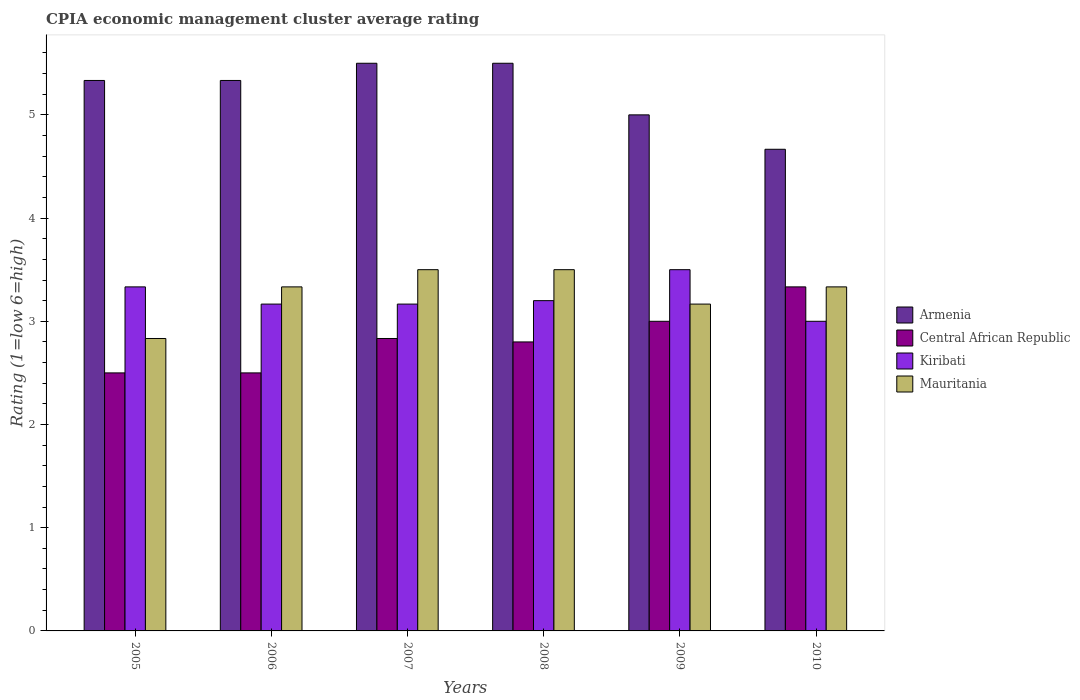How many different coloured bars are there?
Your answer should be compact. 4. How many groups of bars are there?
Your answer should be compact. 6. How many bars are there on the 3rd tick from the left?
Give a very brief answer. 4. How many bars are there on the 1st tick from the right?
Offer a very short reply. 4. What is the label of the 4th group of bars from the left?
Your response must be concise. 2008. In how many cases, is the number of bars for a given year not equal to the number of legend labels?
Your answer should be compact. 0. Across all years, what is the maximum CPIA rating in Mauritania?
Ensure brevity in your answer.  3.5. Across all years, what is the minimum CPIA rating in Armenia?
Provide a short and direct response. 4.67. In which year was the CPIA rating in Armenia maximum?
Your response must be concise. 2007. What is the total CPIA rating in Armenia in the graph?
Your answer should be compact. 31.33. What is the difference between the CPIA rating in Central African Republic in 2007 and that in 2008?
Provide a short and direct response. 0.03. What is the difference between the CPIA rating in Central African Republic in 2010 and the CPIA rating in Mauritania in 2009?
Give a very brief answer. 0.17. What is the average CPIA rating in Central African Republic per year?
Give a very brief answer. 2.83. In the year 2010, what is the difference between the CPIA rating in Armenia and CPIA rating in Mauritania?
Give a very brief answer. 1.33. In how many years, is the CPIA rating in Mauritania greater than 2.2?
Your response must be concise. 6. What is the ratio of the CPIA rating in Mauritania in 2005 to that in 2006?
Your response must be concise. 0.85. Is the difference between the CPIA rating in Armenia in 2008 and 2009 greater than the difference between the CPIA rating in Mauritania in 2008 and 2009?
Your answer should be compact. Yes. What is the difference between the highest and the lowest CPIA rating in Central African Republic?
Provide a succinct answer. 0.83. In how many years, is the CPIA rating in Central African Republic greater than the average CPIA rating in Central African Republic taken over all years?
Ensure brevity in your answer.  3. Is the sum of the CPIA rating in Kiribati in 2005 and 2006 greater than the maximum CPIA rating in Mauritania across all years?
Ensure brevity in your answer.  Yes. What does the 2nd bar from the left in 2010 represents?
Offer a terse response. Central African Republic. What does the 3rd bar from the right in 2009 represents?
Make the answer very short. Central African Republic. Is it the case that in every year, the sum of the CPIA rating in Kiribati and CPIA rating in Armenia is greater than the CPIA rating in Mauritania?
Give a very brief answer. Yes. Are all the bars in the graph horizontal?
Ensure brevity in your answer.  No. How many years are there in the graph?
Make the answer very short. 6. Are the values on the major ticks of Y-axis written in scientific E-notation?
Provide a succinct answer. No. Does the graph contain grids?
Give a very brief answer. No. What is the title of the graph?
Your answer should be compact. CPIA economic management cluster average rating. What is the label or title of the Y-axis?
Give a very brief answer. Rating (1=low 6=high). What is the Rating (1=low 6=high) of Armenia in 2005?
Offer a terse response. 5.33. What is the Rating (1=low 6=high) of Kiribati in 2005?
Provide a short and direct response. 3.33. What is the Rating (1=low 6=high) of Mauritania in 2005?
Your answer should be compact. 2.83. What is the Rating (1=low 6=high) of Armenia in 2006?
Provide a short and direct response. 5.33. What is the Rating (1=low 6=high) in Central African Republic in 2006?
Your answer should be very brief. 2.5. What is the Rating (1=low 6=high) of Kiribati in 2006?
Your response must be concise. 3.17. What is the Rating (1=low 6=high) of Mauritania in 2006?
Give a very brief answer. 3.33. What is the Rating (1=low 6=high) in Central African Republic in 2007?
Your answer should be compact. 2.83. What is the Rating (1=low 6=high) of Kiribati in 2007?
Ensure brevity in your answer.  3.17. What is the Rating (1=low 6=high) of Armenia in 2008?
Your answer should be very brief. 5.5. What is the Rating (1=low 6=high) of Armenia in 2009?
Your answer should be very brief. 5. What is the Rating (1=low 6=high) of Mauritania in 2009?
Offer a very short reply. 3.17. What is the Rating (1=low 6=high) in Armenia in 2010?
Your answer should be very brief. 4.67. What is the Rating (1=low 6=high) of Central African Republic in 2010?
Give a very brief answer. 3.33. What is the Rating (1=low 6=high) in Kiribati in 2010?
Offer a terse response. 3. What is the Rating (1=low 6=high) of Mauritania in 2010?
Offer a very short reply. 3.33. Across all years, what is the maximum Rating (1=low 6=high) in Armenia?
Offer a terse response. 5.5. Across all years, what is the maximum Rating (1=low 6=high) in Central African Republic?
Your answer should be very brief. 3.33. Across all years, what is the minimum Rating (1=low 6=high) in Armenia?
Make the answer very short. 4.67. Across all years, what is the minimum Rating (1=low 6=high) in Central African Republic?
Your answer should be compact. 2.5. Across all years, what is the minimum Rating (1=low 6=high) of Kiribati?
Your answer should be very brief. 3. Across all years, what is the minimum Rating (1=low 6=high) of Mauritania?
Your response must be concise. 2.83. What is the total Rating (1=low 6=high) in Armenia in the graph?
Make the answer very short. 31.33. What is the total Rating (1=low 6=high) in Central African Republic in the graph?
Your answer should be very brief. 16.97. What is the total Rating (1=low 6=high) in Kiribati in the graph?
Your answer should be compact. 19.37. What is the total Rating (1=low 6=high) in Mauritania in the graph?
Ensure brevity in your answer.  19.67. What is the difference between the Rating (1=low 6=high) in Armenia in 2005 and that in 2006?
Ensure brevity in your answer.  0. What is the difference between the Rating (1=low 6=high) of Central African Republic in 2005 and that in 2006?
Make the answer very short. 0. What is the difference between the Rating (1=low 6=high) of Kiribati in 2005 and that in 2006?
Keep it short and to the point. 0.17. What is the difference between the Rating (1=low 6=high) of Kiribati in 2005 and that in 2007?
Keep it short and to the point. 0.17. What is the difference between the Rating (1=low 6=high) in Central African Republic in 2005 and that in 2008?
Make the answer very short. -0.3. What is the difference between the Rating (1=low 6=high) of Kiribati in 2005 and that in 2008?
Make the answer very short. 0.13. What is the difference between the Rating (1=low 6=high) of Armenia in 2005 and that in 2010?
Provide a succinct answer. 0.67. What is the difference between the Rating (1=low 6=high) of Central African Republic in 2005 and that in 2010?
Your answer should be compact. -0.83. What is the difference between the Rating (1=low 6=high) of Central African Republic in 2006 and that in 2007?
Make the answer very short. -0.33. What is the difference between the Rating (1=low 6=high) of Kiribati in 2006 and that in 2007?
Ensure brevity in your answer.  0. What is the difference between the Rating (1=low 6=high) in Mauritania in 2006 and that in 2007?
Provide a succinct answer. -0.17. What is the difference between the Rating (1=low 6=high) in Armenia in 2006 and that in 2008?
Provide a succinct answer. -0.17. What is the difference between the Rating (1=low 6=high) in Kiribati in 2006 and that in 2008?
Offer a terse response. -0.03. What is the difference between the Rating (1=low 6=high) in Armenia in 2006 and that in 2009?
Make the answer very short. 0.33. What is the difference between the Rating (1=low 6=high) in Central African Republic in 2006 and that in 2009?
Offer a terse response. -0.5. What is the difference between the Rating (1=low 6=high) in Mauritania in 2006 and that in 2009?
Offer a very short reply. 0.17. What is the difference between the Rating (1=low 6=high) of Central African Republic in 2006 and that in 2010?
Your response must be concise. -0.83. What is the difference between the Rating (1=low 6=high) of Mauritania in 2006 and that in 2010?
Give a very brief answer. 0. What is the difference between the Rating (1=low 6=high) of Armenia in 2007 and that in 2008?
Ensure brevity in your answer.  0. What is the difference between the Rating (1=low 6=high) in Central African Republic in 2007 and that in 2008?
Offer a very short reply. 0.03. What is the difference between the Rating (1=low 6=high) of Kiribati in 2007 and that in 2008?
Your answer should be very brief. -0.03. What is the difference between the Rating (1=low 6=high) of Mauritania in 2007 and that in 2008?
Give a very brief answer. 0. What is the difference between the Rating (1=low 6=high) in Armenia in 2007 and that in 2009?
Ensure brevity in your answer.  0.5. What is the difference between the Rating (1=low 6=high) in Kiribati in 2007 and that in 2009?
Provide a succinct answer. -0.33. What is the difference between the Rating (1=low 6=high) of Armenia in 2008 and that in 2009?
Offer a very short reply. 0.5. What is the difference between the Rating (1=low 6=high) in Mauritania in 2008 and that in 2009?
Offer a very short reply. 0.33. What is the difference between the Rating (1=low 6=high) in Central African Republic in 2008 and that in 2010?
Offer a terse response. -0.53. What is the difference between the Rating (1=low 6=high) in Kiribati in 2008 and that in 2010?
Provide a succinct answer. 0.2. What is the difference between the Rating (1=low 6=high) in Mauritania in 2008 and that in 2010?
Give a very brief answer. 0.17. What is the difference between the Rating (1=low 6=high) in Armenia in 2009 and that in 2010?
Your response must be concise. 0.33. What is the difference between the Rating (1=low 6=high) in Kiribati in 2009 and that in 2010?
Give a very brief answer. 0.5. What is the difference between the Rating (1=low 6=high) in Mauritania in 2009 and that in 2010?
Offer a very short reply. -0.17. What is the difference between the Rating (1=low 6=high) in Armenia in 2005 and the Rating (1=low 6=high) in Central African Republic in 2006?
Your answer should be compact. 2.83. What is the difference between the Rating (1=low 6=high) in Armenia in 2005 and the Rating (1=low 6=high) in Kiribati in 2006?
Your answer should be very brief. 2.17. What is the difference between the Rating (1=low 6=high) in Armenia in 2005 and the Rating (1=low 6=high) in Mauritania in 2006?
Make the answer very short. 2. What is the difference between the Rating (1=low 6=high) of Kiribati in 2005 and the Rating (1=low 6=high) of Mauritania in 2006?
Give a very brief answer. 0. What is the difference between the Rating (1=low 6=high) of Armenia in 2005 and the Rating (1=low 6=high) of Central African Republic in 2007?
Your answer should be very brief. 2.5. What is the difference between the Rating (1=low 6=high) of Armenia in 2005 and the Rating (1=low 6=high) of Kiribati in 2007?
Provide a short and direct response. 2.17. What is the difference between the Rating (1=low 6=high) of Armenia in 2005 and the Rating (1=low 6=high) of Mauritania in 2007?
Make the answer very short. 1.83. What is the difference between the Rating (1=low 6=high) of Central African Republic in 2005 and the Rating (1=low 6=high) of Kiribati in 2007?
Your answer should be very brief. -0.67. What is the difference between the Rating (1=low 6=high) of Central African Republic in 2005 and the Rating (1=low 6=high) of Mauritania in 2007?
Offer a terse response. -1. What is the difference between the Rating (1=low 6=high) of Kiribati in 2005 and the Rating (1=low 6=high) of Mauritania in 2007?
Your answer should be compact. -0.17. What is the difference between the Rating (1=low 6=high) of Armenia in 2005 and the Rating (1=low 6=high) of Central African Republic in 2008?
Provide a succinct answer. 2.53. What is the difference between the Rating (1=low 6=high) in Armenia in 2005 and the Rating (1=low 6=high) in Kiribati in 2008?
Offer a terse response. 2.13. What is the difference between the Rating (1=low 6=high) in Armenia in 2005 and the Rating (1=low 6=high) in Mauritania in 2008?
Give a very brief answer. 1.83. What is the difference between the Rating (1=low 6=high) in Central African Republic in 2005 and the Rating (1=low 6=high) in Kiribati in 2008?
Ensure brevity in your answer.  -0.7. What is the difference between the Rating (1=low 6=high) of Central African Republic in 2005 and the Rating (1=low 6=high) of Mauritania in 2008?
Offer a terse response. -1. What is the difference between the Rating (1=low 6=high) of Armenia in 2005 and the Rating (1=low 6=high) of Central African Republic in 2009?
Offer a terse response. 2.33. What is the difference between the Rating (1=low 6=high) in Armenia in 2005 and the Rating (1=low 6=high) in Kiribati in 2009?
Ensure brevity in your answer.  1.83. What is the difference between the Rating (1=low 6=high) in Armenia in 2005 and the Rating (1=low 6=high) in Mauritania in 2009?
Keep it short and to the point. 2.17. What is the difference between the Rating (1=low 6=high) of Kiribati in 2005 and the Rating (1=low 6=high) of Mauritania in 2009?
Give a very brief answer. 0.17. What is the difference between the Rating (1=low 6=high) of Armenia in 2005 and the Rating (1=low 6=high) of Kiribati in 2010?
Keep it short and to the point. 2.33. What is the difference between the Rating (1=low 6=high) of Central African Republic in 2005 and the Rating (1=low 6=high) of Kiribati in 2010?
Make the answer very short. -0.5. What is the difference between the Rating (1=low 6=high) in Armenia in 2006 and the Rating (1=low 6=high) in Central African Republic in 2007?
Provide a short and direct response. 2.5. What is the difference between the Rating (1=low 6=high) of Armenia in 2006 and the Rating (1=low 6=high) of Kiribati in 2007?
Make the answer very short. 2.17. What is the difference between the Rating (1=low 6=high) in Armenia in 2006 and the Rating (1=low 6=high) in Mauritania in 2007?
Offer a terse response. 1.83. What is the difference between the Rating (1=low 6=high) of Central African Republic in 2006 and the Rating (1=low 6=high) of Kiribati in 2007?
Keep it short and to the point. -0.67. What is the difference between the Rating (1=low 6=high) of Central African Republic in 2006 and the Rating (1=low 6=high) of Mauritania in 2007?
Ensure brevity in your answer.  -1. What is the difference between the Rating (1=low 6=high) in Kiribati in 2006 and the Rating (1=low 6=high) in Mauritania in 2007?
Offer a terse response. -0.33. What is the difference between the Rating (1=low 6=high) in Armenia in 2006 and the Rating (1=low 6=high) in Central African Republic in 2008?
Provide a succinct answer. 2.53. What is the difference between the Rating (1=low 6=high) of Armenia in 2006 and the Rating (1=low 6=high) of Kiribati in 2008?
Your response must be concise. 2.13. What is the difference between the Rating (1=low 6=high) of Armenia in 2006 and the Rating (1=low 6=high) of Mauritania in 2008?
Your response must be concise. 1.83. What is the difference between the Rating (1=low 6=high) of Central African Republic in 2006 and the Rating (1=low 6=high) of Kiribati in 2008?
Give a very brief answer. -0.7. What is the difference between the Rating (1=low 6=high) in Central African Republic in 2006 and the Rating (1=low 6=high) in Mauritania in 2008?
Your answer should be very brief. -1. What is the difference between the Rating (1=low 6=high) in Kiribati in 2006 and the Rating (1=low 6=high) in Mauritania in 2008?
Offer a terse response. -0.33. What is the difference between the Rating (1=low 6=high) of Armenia in 2006 and the Rating (1=low 6=high) of Central African Republic in 2009?
Make the answer very short. 2.33. What is the difference between the Rating (1=low 6=high) in Armenia in 2006 and the Rating (1=low 6=high) in Kiribati in 2009?
Give a very brief answer. 1.83. What is the difference between the Rating (1=low 6=high) in Armenia in 2006 and the Rating (1=low 6=high) in Mauritania in 2009?
Offer a very short reply. 2.17. What is the difference between the Rating (1=low 6=high) in Kiribati in 2006 and the Rating (1=low 6=high) in Mauritania in 2009?
Offer a very short reply. 0. What is the difference between the Rating (1=low 6=high) of Armenia in 2006 and the Rating (1=low 6=high) of Central African Republic in 2010?
Provide a succinct answer. 2. What is the difference between the Rating (1=low 6=high) of Armenia in 2006 and the Rating (1=low 6=high) of Kiribati in 2010?
Keep it short and to the point. 2.33. What is the difference between the Rating (1=low 6=high) of Armenia in 2006 and the Rating (1=low 6=high) of Mauritania in 2010?
Offer a terse response. 2. What is the difference between the Rating (1=low 6=high) in Central African Republic in 2006 and the Rating (1=low 6=high) in Kiribati in 2010?
Give a very brief answer. -0.5. What is the difference between the Rating (1=low 6=high) in Armenia in 2007 and the Rating (1=low 6=high) in Kiribati in 2008?
Give a very brief answer. 2.3. What is the difference between the Rating (1=low 6=high) of Armenia in 2007 and the Rating (1=low 6=high) of Mauritania in 2008?
Give a very brief answer. 2. What is the difference between the Rating (1=low 6=high) in Central African Republic in 2007 and the Rating (1=low 6=high) in Kiribati in 2008?
Offer a terse response. -0.37. What is the difference between the Rating (1=low 6=high) of Kiribati in 2007 and the Rating (1=low 6=high) of Mauritania in 2008?
Keep it short and to the point. -0.33. What is the difference between the Rating (1=low 6=high) of Armenia in 2007 and the Rating (1=low 6=high) of Central African Republic in 2009?
Your answer should be very brief. 2.5. What is the difference between the Rating (1=low 6=high) in Armenia in 2007 and the Rating (1=low 6=high) in Kiribati in 2009?
Keep it short and to the point. 2. What is the difference between the Rating (1=low 6=high) in Armenia in 2007 and the Rating (1=low 6=high) in Mauritania in 2009?
Provide a succinct answer. 2.33. What is the difference between the Rating (1=low 6=high) of Central African Republic in 2007 and the Rating (1=low 6=high) of Kiribati in 2009?
Provide a short and direct response. -0.67. What is the difference between the Rating (1=low 6=high) in Central African Republic in 2007 and the Rating (1=low 6=high) in Mauritania in 2009?
Keep it short and to the point. -0.33. What is the difference between the Rating (1=low 6=high) of Kiribati in 2007 and the Rating (1=low 6=high) of Mauritania in 2009?
Your answer should be very brief. 0. What is the difference between the Rating (1=low 6=high) of Armenia in 2007 and the Rating (1=low 6=high) of Central African Republic in 2010?
Your response must be concise. 2.17. What is the difference between the Rating (1=low 6=high) of Armenia in 2007 and the Rating (1=low 6=high) of Mauritania in 2010?
Make the answer very short. 2.17. What is the difference between the Rating (1=low 6=high) of Central African Republic in 2007 and the Rating (1=low 6=high) of Kiribati in 2010?
Keep it short and to the point. -0.17. What is the difference between the Rating (1=low 6=high) in Armenia in 2008 and the Rating (1=low 6=high) in Kiribati in 2009?
Make the answer very short. 2. What is the difference between the Rating (1=low 6=high) in Armenia in 2008 and the Rating (1=low 6=high) in Mauritania in 2009?
Offer a very short reply. 2.33. What is the difference between the Rating (1=low 6=high) in Central African Republic in 2008 and the Rating (1=low 6=high) in Mauritania in 2009?
Offer a very short reply. -0.37. What is the difference between the Rating (1=low 6=high) of Armenia in 2008 and the Rating (1=low 6=high) of Central African Republic in 2010?
Offer a terse response. 2.17. What is the difference between the Rating (1=low 6=high) of Armenia in 2008 and the Rating (1=low 6=high) of Mauritania in 2010?
Your answer should be compact. 2.17. What is the difference between the Rating (1=low 6=high) in Central African Republic in 2008 and the Rating (1=low 6=high) in Kiribati in 2010?
Your answer should be very brief. -0.2. What is the difference between the Rating (1=low 6=high) of Central African Republic in 2008 and the Rating (1=low 6=high) of Mauritania in 2010?
Provide a succinct answer. -0.53. What is the difference between the Rating (1=low 6=high) of Kiribati in 2008 and the Rating (1=low 6=high) of Mauritania in 2010?
Offer a very short reply. -0.13. What is the difference between the Rating (1=low 6=high) of Armenia in 2009 and the Rating (1=low 6=high) of Kiribati in 2010?
Provide a short and direct response. 2. What is the difference between the Rating (1=low 6=high) of Armenia in 2009 and the Rating (1=low 6=high) of Mauritania in 2010?
Ensure brevity in your answer.  1.67. What is the difference between the Rating (1=low 6=high) of Central African Republic in 2009 and the Rating (1=low 6=high) of Kiribati in 2010?
Keep it short and to the point. 0. What is the difference between the Rating (1=low 6=high) in Central African Republic in 2009 and the Rating (1=low 6=high) in Mauritania in 2010?
Keep it short and to the point. -0.33. What is the difference between the Rating (1=low 6=high) in Kiribati in 2009 and the Rating (1=low 6=high) in Mauritania in 2010?
Offer a very short reply. 0.17. What is the average Rating (1=low 6=high) of Armenia per year?
Offer a very short reply. 5.22. What is the average Rating (1=low 6=high) of Central African Republic per year?
Your answer should be very brief. 2.83. What is the average Rating (1=low 6=high) of Kiribati per year?
Your response must be concise. 3.23. What is the average Rating (1=low 6=high) in Mauritania per year?
Give a very brief answer. 3.28. In the year 2005, what is the difference between the Rating (1=low 6=high) of Armenia and Rating (1=low 6=high) of Central African Republic?
Your answer should be compact. 2.83. In the year 2005, what is the difference between the Rating (1=low 6=high) of Armenia and Rating (1=low 6=high) of Kiribati?
Your answer should be very brief. 2. In the year 2005, what is the difference between the Rating (1=low 6=high) of Central African Republic and Rating (1=low 6=high) of Mauritania?
Offer a terse response. -0.33. In the year 2005, what is the difference between the Rating (1=low 6=high) in Kiribati and Rating (1=low 6=high) in Mauritania?
Offer a terse response. 0.5. In the year 2006, what is the difference between the Rating (1=low 6=high) of Armenia and Rating (1=low 6=high) of Central African Republic?
Give a very brief answer. 2.83. In the year 2006, what is the difference between the Rating (1=low 6=high) in Armenia and Rating (1=low 6=high) in Kiribati?
Give a very brief answer. 2.17. In the year 2006, what is the difference between the Rating (1=low 6=high) in Armenia and Rating (1=low 6=high) in Mauritania?
Offer a very short reply. 2. In the year 2006, what is the difference between the Rating (1=low 6=high) of Central African Republic and Rating (1=low 6=high) of Mauritania?
Make the answer very short. -0.83. In the year 2006, what is the difference between the Rating (1=low 6=high) of Kiribati and Rating (1=low 6=high) of Mauritania?
Give a very brief answer. -0.17. In the year 2007, what is the difference between the Rating (1=low 6=high) of Armenia and Rating (1=low 6=high) of Central African Republic?
Keep it short and to the point. 2.67. In the year 2007, what is the difference between the Rating (1=low 6=high) of Armenia and Rating (1=low 6=high) of Kiribati?
Keep it short and to the point. 2.33. In the year 2007, what is the difference between the Rating (1=low 6=high) in Armenia and Rating (1=low 6=high) in Mauritania?
Ensure brevity in your answer.  2. In the year 2008, what is the difference between the Rating (1=low 6=high) of Armenia and Rating (1=low 6=high) of Central African Republic?
Offer a very short reply. 2.7. In the year 2008, what is the difference between the Rating (1=low 6=high) of Armenia and Rating (1=low 6=high) of Kiribati?
Ensure brevity in your answer.  2.3. In the year 2008, what is the difference between the Rating (1=low 6=high) of Armenia and Rating (1=low 6=high) of Mauritania?
Make the answer very short. 2. In the year 2008, what is the difference between the Rating (1=low 6=high) of Central African Republic and Rating (1=low 6=high) of Mauritania?
Your response must be concise. -0.7. In the year 2008, what is the difference between the Rating (1=low 6=high) of Kiribati and Rating (1=low 6=high) of Mauritania?
Make the answer very short. -0.3. In the year 2009, what is the difference between the Rating (1=low 6=high) in Armenia and Rating (1=low 6=high) in Central African Republic?
Provide a short and direct response. 2. In the year 2009, what is the difference between the Rating (1=low 6=high) in Armenia and Rating (1=low 6=high) in Mauritania?
Your response must be concise. 1.83. In the year 2009, what is the difference between the Rating (1=low 6=high) in Central African Republic and Rating (1=low 6=high) in Kiribati?
Make the answer very short. -0.5. In the year 2009, what is the difference between the Rating (1=low 6=high) in Central African Republic and Rating (1=low 6=high) in Mauritania?
Offer a very short reply. -0.17. In the year 2009, what is the difference between the Rating (1=low 6=high) in Kiribati and Rating (1=low 6=high) in Mauritania?
Your response must be concise. 0.33. In the year 2010, what is the difference between the Rating (1=low 6=high) of Armenia and Rating (1=low 6=high) of Kiribati?
Your response must be concise. 1.67. In the year 2010, what is the difference between the Rating (1=low 6=high) of Central African Republic and Rating (1=low 6=high) of Kiribati?
Provide a succinct answer. 0.33. What is the ratio of the Rating (1=low 6=high) in Armenia in 2005 to that in 2006?
Provide a short and direct response. 1. What is the ratio of the Rating (1=low 6=high) in Kiribati in 2005 to that in 2006?
Offer a terse response. 1.05. What is the ratio of the Rating (1=low 6=high) in Mauritania in 2005 to that in 2006?
Ensure brevity in your answer.  0.85. What is the ratio of the Rating (1=low 6=high) in Armenia in 2005 to that in 2007?
Your answer should be very brief. 0.97. What is the ratio of the Rating (1=low 6=high) of Central African Republic in 2005 to that in 2007?
Your response must be concise. 0.88. What is the ratio of the Rating (1=low 6=high) of Kiribati in 2005 to that in 2007?
Ensure brevity in your answer.  1.05. What is the ratio of the Rating (1=low 6=high) in Mauritania in 2005 to that in 2007?
Ensure brevity in your answer.  0.81. What is the ratio of the Rating (1=low 6=high) in Armenia in 2005 to that in 2008?
Make the answer very short. 0.97. What is the ratio of the Rating (1=low 6=high) in Central African Republic in 2005 to that in 2008?
Provide a succinct answer. 0.89. What is the ratio of the Rating (1=low 6=high) in Kiribati in 2005 to that in 2008?
Keep it short and to the point. 1.04. What is the ratio of the Rating (1=low 6=high) in Mauritania in 2005 to that in 2008?
Provide a short and direct response. 0.81. What is the ratio of the Rating (1=low 6=high) of Armenia in 2005 to that in 2009?
Provide a succinct answer. 1.07. What is the ratio of the Rating (1=low 6=high) of Central African Republic in 2005 to that in 2009?
Your response must be concise. 0.83. What is the ratio of the Rating (1=low 6=high) in Kiribati in 2005 to that in 2009?
Keep it short and to the point. 0.95. What is the ratio of the Rating (1=low 6=high) in Mauritania in 2005 to that in 2009?
Provide a short and direct response. 0.89. What is the ratio of the Rating (1=low 6=high) of Mauritania in 2005 to that in 2010?
Your response must be concise. 0.85. What is the ratio of the Rating (1=low 6=high) in Armenia in 2006 to that in 2007?
Offer a very short reply. 0.97. What is the ratio of the Rating (1=low 6=high) in Central African Republic in 2006 to that in 2007?
Offer a terse response. 0.88. What is the ratio of the Rating (1=low 6=high) in Armenia in 2006 to that in 2008?
Offer a terse response. 0.97. What is the ratio of the Rating (1=low 6=high) of Central African Republic in 2006 to that in 2008?
Your response must be concise. 0.89. What is the ratio of the Rating (1=low 6=high) in Kiribati in 2006 to that in 2008?
Ensure brevity in your answer.  0.99. What is the ratio of the Rating (1=low 6=high) in Armenia in 2006 to that in 2009?
Offer a very short reply. 1.07. What is the ratio of the Rating (1=low 6=high) of Central African Republic in 2006 to that in 2009?
Your answer should be very brief. 0.83. What is the ratio of the Rating (1=low 6=high) of Kiribati in 2006 to that in 2009?
Keep it short and to the point. 0.9. What is the ratio of the Rating (1=low 6=high) of Mauritania in 2006 to that in 2009?
Provide a short and direct response. 1.05. What is the ratio of the Rating (1=low 6=high) of Kiribati in 2006 to that in 2010?
Your answer should be very brief. 1.06. What is the ratio of the Rating (1=low 6=high) of Mauritania in 2006 to that in 2010?
Give a very brief answer. 1. What is the ratio of the Rating (1=low 6=high) in Central African Republic in 2007 to that in 2008?
Provide a short and direct response. 1.01. What is the ratio of the Rating (1=low 6=high) of Mauritania in 2007 to that in 2008?
Provide a succinct answer. 1. What is the ratio of the Rating (1=low 6=high) of Kiribati in 2007 to that in 2009?
Keep it short and to the point. 0.9. What is the ratio of the Rating (1=low 6=high) of Mauritania in 2007 to that in 2009?
Offer a terse response. 1.11. What is the ratio of the Rating (1=low 6=high) of Armenia in 2007 to that in 2010?
Give a very brief answer. 1.18. What is the ratio of the Rating (1=low 6=high) of Central African Republic in 2007 to that in 2010?
Provide a short and direct response. 0.85. What is the ratio of the Rating (1=low 6=high) of Kiribati in 2007 to that in 2010?
Provide a short and direct response. 1.06. What is the ratio of the Rating (1=low 6=high) of Mauritania in 2007 to that in 2010?
Provide a succinct answer. 1.05. What is the ratio of the Rating (1=low 6=high) of Armenia in 2008 to that in 2009?
Offer a very short reply. 1.1. What is the ratio of the Rating (1=low 6=high) in Kiribati in 2008 to that in 2009?
Keep it short and to the point. 0.91. What is the ratio of the Rating (1=low 6=high) of Mauritania in 2008 to that in 2009?
Provide a short and direct response. 1.11. What is the ratio of the Rating (1=low 6=high) of Armenia in 2008 to that in 2010?
Your answer should be compact. 1.18. What is the ratio of the Rating (1=low 6=high) of Central African Republic in 2008 to that in 2010?
Make the answer very short. 0.84. What is the ratio of the Rating (1=low 6=high) in Kiribati in 2008 to that in 2010?
Provide a short and direct response. 1.07. What is the ratio of the Rating (1=low 6=high) of Mauritania in 2008 to that in 2010?
Make the answer very short. 1.05. What is the ratio of the Rating (1=low 6=high) in Armenia in 2009 to that in 2010?
Offer a terse response. 1.07. What is the ratio of the Rating (1=low 6=high) in Kiribati in 2009 to that in 2010?
Provide a succinct answer. 1.17. What is the ratio of the Rating (1=low 6=high) of Mauritania in 2009 to that in 2010?
Provide a short and direct response. 0.95. What is the difference between the highest and the second highest Rating (1=low 6=high) of Mauritania?
Your answer should be compact. 0. What is the difference between the highest and the lowest Rating (1=low 6=high) in Central African Republic?
Ensure brevity in your answer.  0.83. What is the difference between the highest and the lowest Rating (1=low 6=high) in Kiribati?
Ensure brevity in your answer.  0.5. 